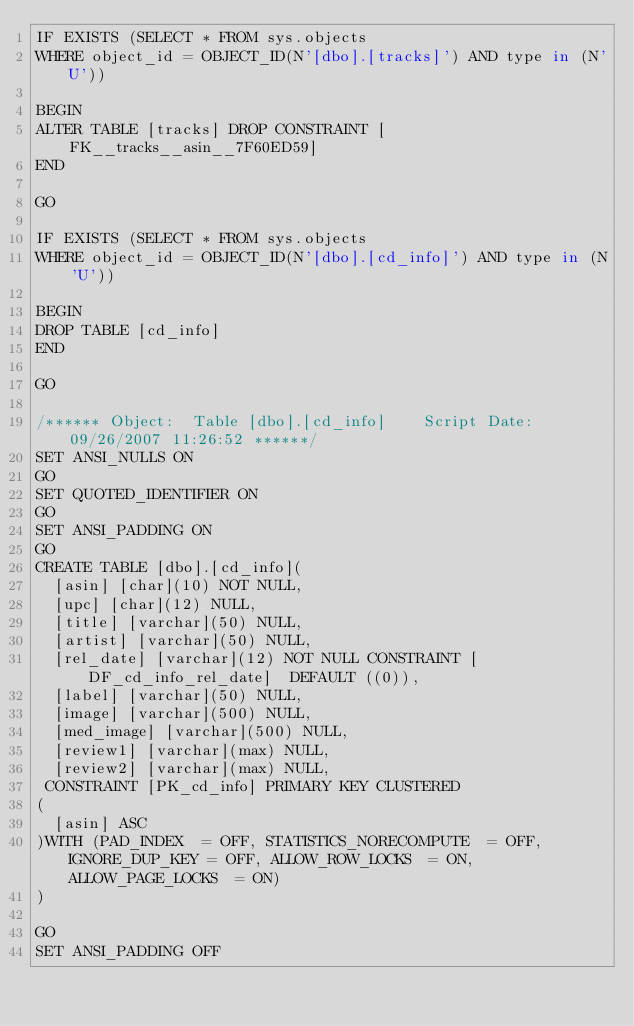Convert code to text. <code><loc_0><loc_0><loc_500><loc_500><_SQL_>IF EXISTS (SELECT * FROM sys.objects 
WHERE object_id = OBJECT_ID(N'[dbo].[tracks]') AND type in (N'U'))

BEGIN
ALTER TABLE [tracks] DROP CONSTRAINT [FK__tracks__asin__7F60ED59]
END

GO

IF EXISTS (SELECT * FROM sys.objects 
WHERE object_id = OBJECT_ID(N'[dbo].[cd_info]') AND type in (N'U'))

BEGIN
DROP TABLE [cd_info]
END

GO

/****** Object:  Table [dbo].[cd_info]    Script Date: 09/26/2007 11:26:52 ******/
SET ANSI_NULLS ON
GO
SET QUOTED_IDENTIFIER ON
GO
SET ANSI_PADDING ON
GO
CREATE TABLE [dbo].[cd_info](
	[asin] [char](10) NOT NULL,
	[upc] [char](12) NULL,
	[title] [varchar](50) NULL,
	[artist] [varchar](50) NULL,
	[rel_date] [varchar](12) NOT NULL CONSTRAINT [DF_cd_info_rel_date]  DEFAULT ((0)),
	[label] [varchar](50) NULL,
	[image] [varchar](500) NULL,
	[med_image] [varchar](500) NULL,
	[review1] [varchar](max) NULL,
	[review2] [varchar](max) NULL,
 CONSTRAINT [PK_cd_info] PRIMARY KEY CLUSTERED 
(
	[asin] ASC
)WITH (PAD_INDEX  = OFF, STATISTICS_NORECOMPUTE  = OFF, IGNORE_DUP_KEY = OFF, ALLOW_ROW_LOCKS  = ON, ALLOW_PAGE_LOCKS  = ON) 
) 

GO
SET ANSI_PADDING OFF</code> 